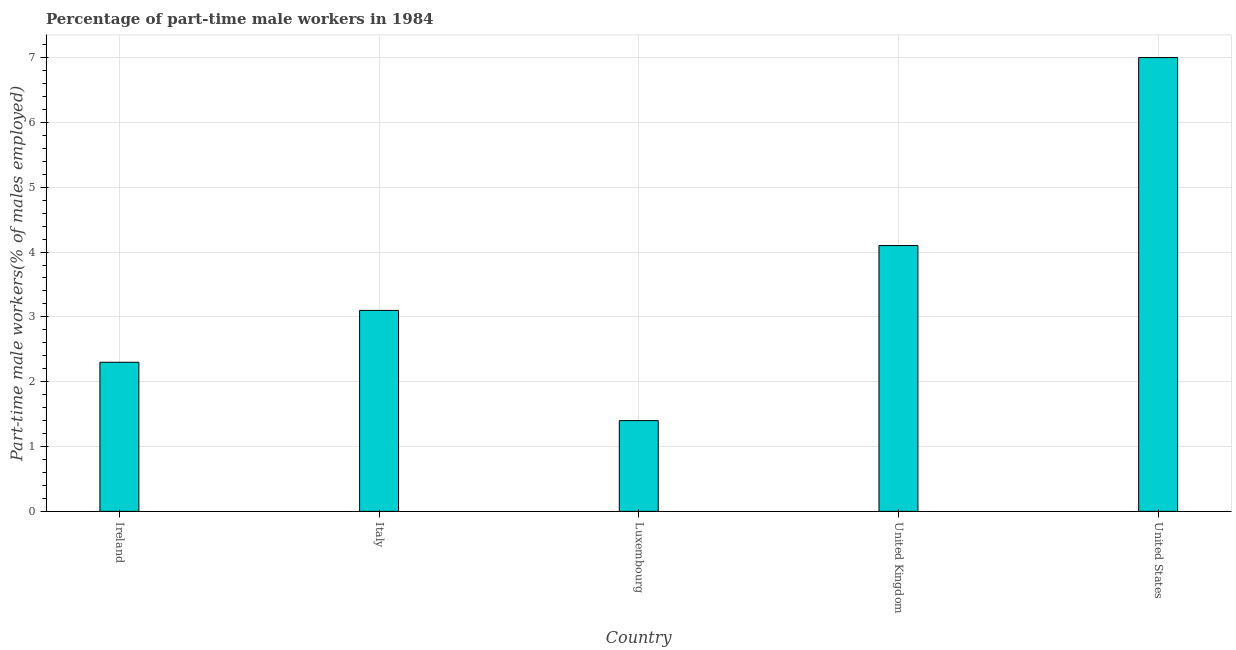Does the graph contain any zero values?
Make the answer very short. No. What is the title of the graph?
Your response must be concise. Percentage of part-time male workers in 1984. What is the label or title of the Y-axis?
Provide a short and direct response. Part-time male workers(% of males employed). What is the percentage of part-time male workers in Italy?
Provide a succinct answer. 3.1. Across all countries, what is the minimum percentage of part-time male workers?
Keep it short and to the point. 1.4. In which country was the percentage of part-time male workers maximum?
Offer a very short reply. United States. In which country was the percentage of part-time male workers minimum?
Ensure brevity in your answer.  Luxembourg. What is the sum of the percentage of part-time male workers?
Provide a short and direct response. 17.9. What is the difference between the percentage of part-time male workers in Ireland and United States?
Provide a succinct answer. -4.7. What is the average percentage of part-time male workers per country?
Offer a very short reply. 3.58. What is the median percentage of part-time male workers?
Ensure brevity in your answer.  3.1. In how many countries, is the percentage of part-time male workers greater than 0.6 %?
Offer a terse response. 5. What is the ratio of the percentage of part-time male workers in Italy to that in United States?
Provide a short and direct response. 0.44. Is the percentage of part-time male workers in Luxembourg less than that in United States?
Keep it short and to the point. Yes. Is the difference between the percentage of part-time male workers in Ireland and Italy greater than the difference between any two countries?
Your response must be concise. No. In how many countries, is the percentage of part-time male workers greater than the average percentage of part-time male workers taken over all countries?
Give a very brief answer. 2. How many bars are there?
Offer a terse response. 5. What is the Part-time male workers(% of males employed) of Ireland?
Make the answer very short. 2.3. What is the Part-time male workers(% of males employed) of Italy?
Keep it short and to the point. 3.1. What is the Part-time male workers(% of males employed) in Luxembourg?
Provide a short and direct response. 1.4. What is the Part-time male workers(% of males employed) in United Kingdom?
Provide a short and direct response. 4.1. What is the difference between the Part-time male workers(% of males employed) in Ireland and Italy?
Provide a short and direct response. -0.8. What is the difference between the Part-time male workers(% of males employed) in Ireland and United Kingdom?
Ensure brevity in your answer.  -1.8. What is the difference between the Part-time male workers(% of males employed) in Ireland and United States?
Keep it short and to the point. -4.7. What is the difference between the Part-time male workers(% of males employed) in Italy and Luxembourg?
Offer a very short reply. 1.7. What is the difference between the Part-time male workers(% of males employed) in Italy and United States?
Offer a terse response. -3.9. What is the ratio of the Part-time male workers(% of males employed) in Ireland to that in Italy?
Make the answer very short. 0.74. What is the ratio of the Part-time male workers(% of males employed) in Ireland to that in Luxembourg?
Offer a very short reply. 1.64. What is the ratio of the Part-time male workers(% of males employed) in Ireland to that in United Kingdom?
Provide a short and direct response. 0.56. What is the ratio of the Part-time male workers(% of males employed) in Ireland to that in United States?
Offer a very short reply. 0.33. What is the ratio of the Part-time male workers(% of males employed) in Italy to that in Luxembourg?
Offer a terse response. 2.21. What is the ratio of the Part-time male workers(% of males employed) in Italy to that in United Kingdom?
Ensure brevity in your answer.  0.76. What is the ratio of the Part-time male workers(% of males employed) in Italy to that in United States?
Give a very brief answer. 0.44. What is the ratio of the Part-time male workers(% of males employed) in Luxembourg to that in United Kingdom?
Your answer should be compact. 0.34. What is the ratio of the Part-time male workers(% of males employed) in United Kingdom to that in United States?
Your response must be concise. 0.59. 